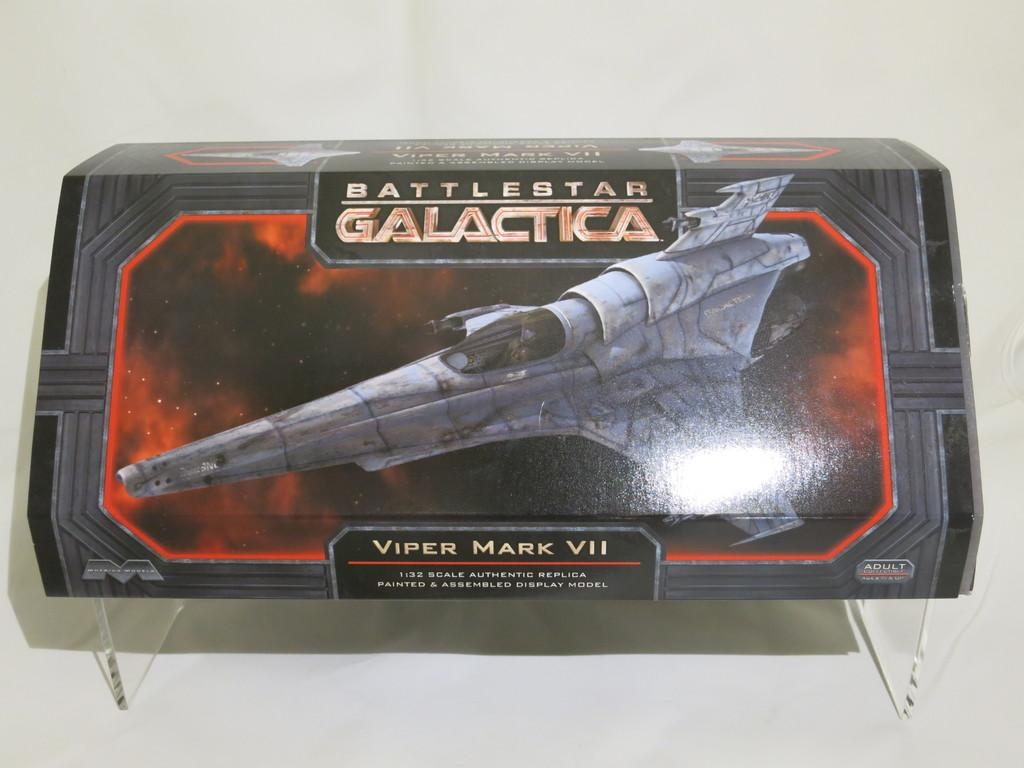Provide a one-sentence caption for the provided image. a painted and assembled Battlestar galactica model is on the table. 